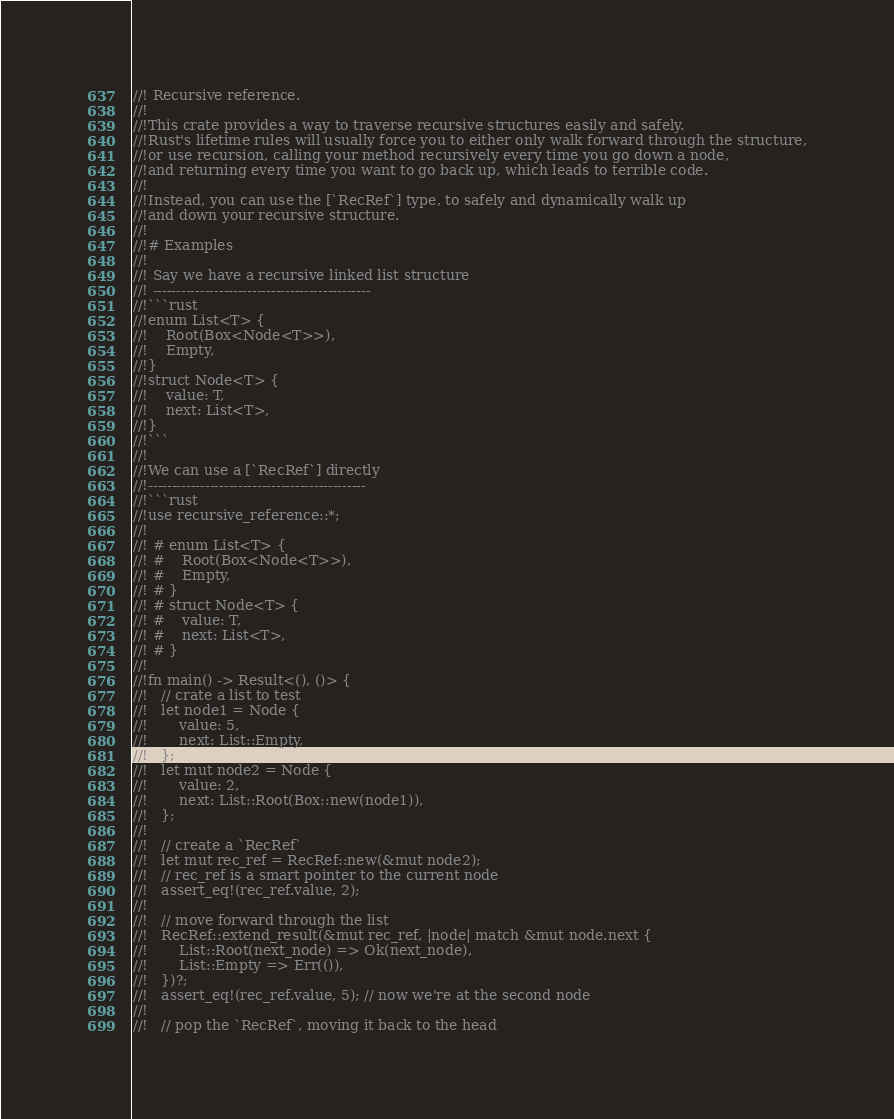Convert code to text. <code><loc_0><loc_0><loc_500><loc_500><_Rust_>//! Recursive reference.
//!
//!This crate provides a way to traverse recursive structures easily and safely.
//!Rust's lifetime rules will usually force you to either only walk forward through the structure,
//!or use recursion, calling your method recursively every time you go down a node,
//!and returning every time you want to go back up, which leads to terrible code.
//!
//!Instead, you can use the [`RecRef`] type, to safely and dynamically walk up
//!and down your recursive structure.
//!
//!# Examples
//!
//! Say we have a recursive linked list structure
//! ----------------------------------------------
//!```rust
//!enum List<T> {
//!    Root(Box<Node<T>>),
//!    Empty,
//!}
//!struct Node<T> {
//!    value: T,
//!    next: List<T>,
//!}
//!```
//!
//!We can use a [`RecRef`] directly
//!----------------------------------------------
//!```rust
//!use recursive_reference::*;
//!
//! # enum List<T> {
//! #    Root(Box<Node<T>>),
//! #    Empty,
//! # }
//! # struct Node<T> {
//! #    value: T,
//! #    next: List<T>,
//! # }
//!
//!fn main() -> Result<(), ()> {
//!   // crate a list to test
//!   let node1 = Node {
//!       value: 5,
//!       next: List::Empty,
//!   };
//!   let mut node2 = Node {
//!       value: 2,
//!       next: List::Root(Box::new(node1)),
//!   };
//!
//!   // create a `RecRef`
//!   let mut rec_ref = RecRef::new(&mut node2);
//!   // rec_ref is a smart pointer to the current node
//!   assert_eq!(rec_ref.value, 2);
//!
//!   // move forward through the list
//!   RecRef::extend_result(&mut rec_ref, |node| match &mut node.next {
//!       List::Root(next_node) => Ok(next_node),
//!       List::Empty => Err(()),
//!   })?;
//!   assert_eq!(rec_ref.value, 5); // now we're at the second node
//!
//!   // pop the `RecRef`, moving it back to the head</code> 